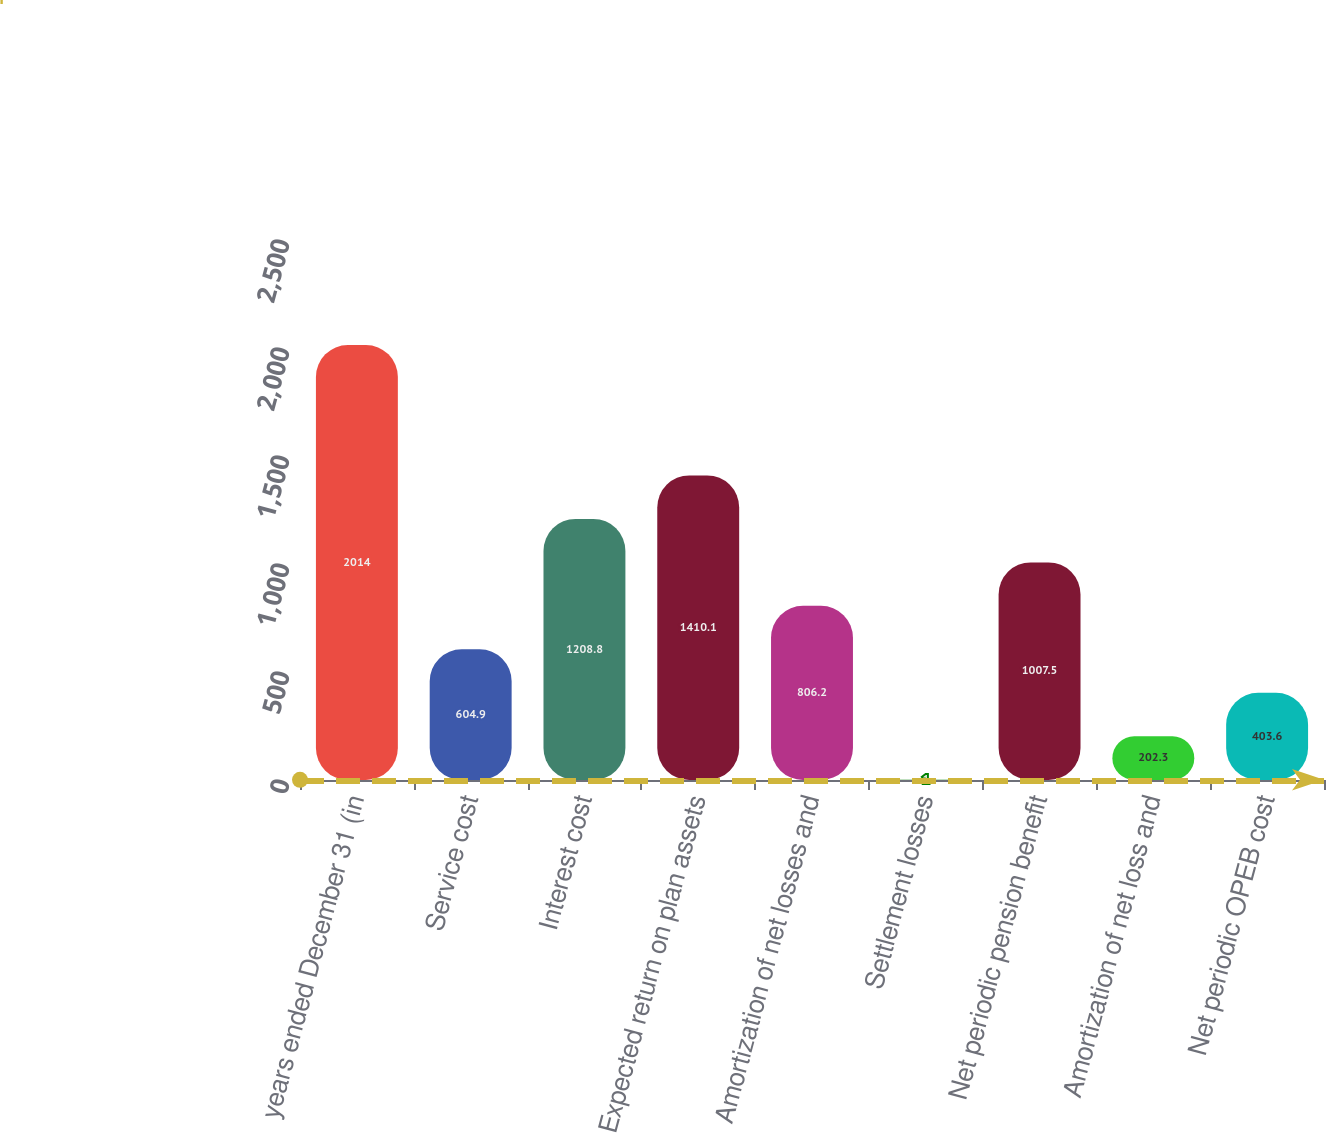<chart> <loc_0><loc_0><loc_500><loc_500><bar_chart><fcel>years ended December 31 (in<fcel>Service cost<fcel>Interest cost<fcel>Expected return on plan assets<fcel>Amortization of net losses and<fcel>Settlement losses<fcel>Net periodic pension benefit<fcel>Amortization of net loss and<fcel>Net periodic OPEB cost<nl><fcel>2014<fcel>604.9<fcel>1208.8<fcel>1410.1<fcel>806.2<fcel>1<fcel>1007.5<fcel>202.3<fcel>403.6<nl></chart> 